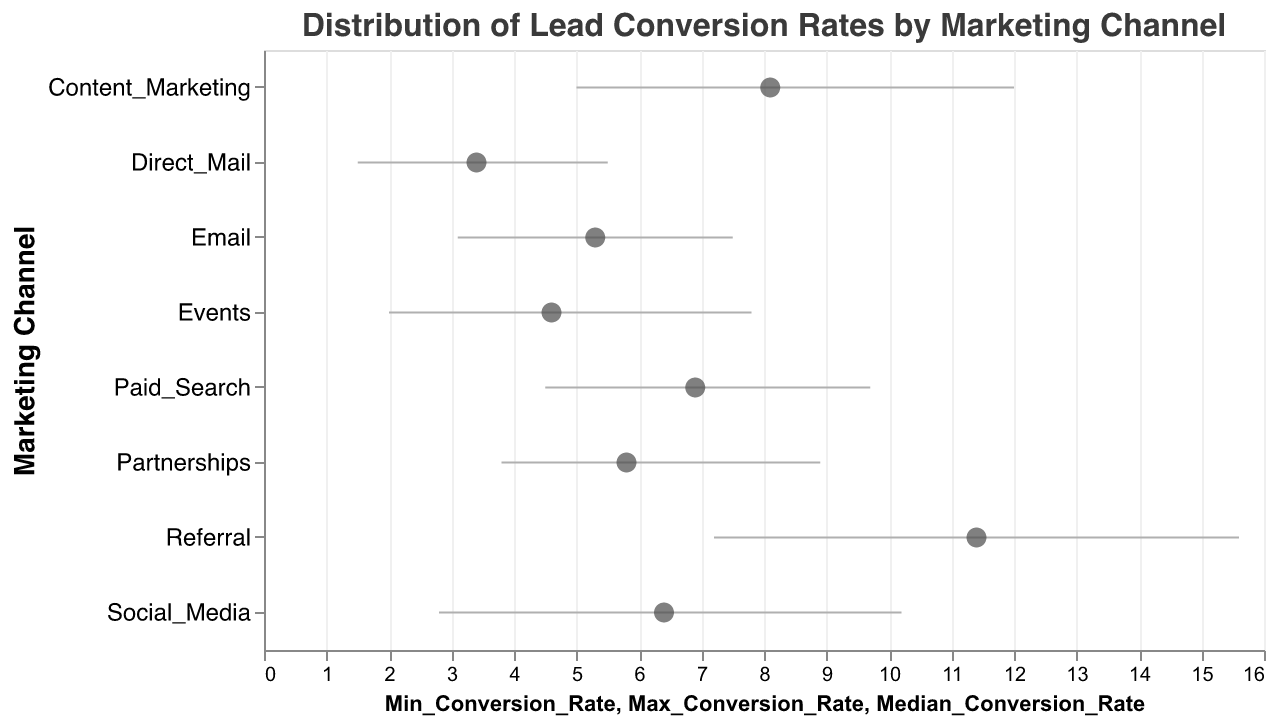What is the title of the plot? The title of the plot is displayed at the top center and reads "Distribution of Lead Conversion Rates by Marketing Channel".
Answer: Distribution of Lead Conversion Rates by Marketing Channel Which marketing channel has the highest median conversion rate? By looking at the points on the plot, the marketing channel with the highest median conversion rate is the highest dot on the horizontal axis. This channel is "Referral".
Answer: Referral How does the median conversion rate of "Direct Mail" compare to "Social Media"? "Direct Mail" has a median conversion rate of 3.4, and "Social Media" has a median conversion rate of 6.4. So, "Social Media" has a higher median conversion rate compared to "Direct Mail".
Answer: Social Media What is the range of conversion rates for "Content Marketing"? The range of conversion rates for "Content Marketing" is calculated by subtracting the minimum rate from the maximum rate (12.0 - 5.0).
Answer: 7.0 Which marketing channel has the widest range of conversion rates? The widest range is determined by comparing the length of the rule marks for each category. "Referral" has the widest range with 15.6 - 7.2 = 8.4.
Answer: Referral What is the median conversion rate for "Paid Search"? By referencing the plotted data points, the median conversion rate of "Paid Search" is indicated by the dot on its corresponding rule mark. The rate is 6.9.
Answer: 6.9 Does "Email" or "Partnerships" have a higher minimum conversion rate? Compare the starting points of the rule marks. "Email" has a minimum conversion rate of 3.1 while "Partnerships" has a minimum of 3.8. Thus, "Partnerships" has a higher minimum conversion rate.
Answer: Partnerships How many marketing channels have a median conversion rate above 7? Identify the dots (median values) that lie above the 7 mark on the x-axis. "Content Marketing" and "Referral" are the only ones above 7.
Answer: 2 Which channel shows the least variability in conversion rates? The least variability is observed by looking for the shortest rule mark. "Direct Mail" has the smallest range from 1.5 to 5.5, making it the least variable.
Answer: Direct Mail 